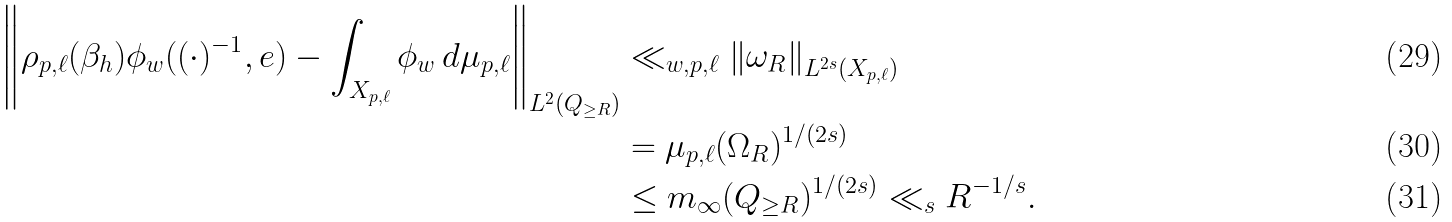Convert formula to latex. <formula><loc_0><loc_0><loc_500><loc_500>\left \| \rho _ { p , \ell } ( \beta _ { h } ) \phi _ { w } ( ( \cdot ) ^ { - 1 } , e ) - \int _ { X _ { p , \ell } } \phi _ { w } \, d \mu _ { p , \ell } \right \| _ { L ^ { 2 } ( Q _ { \geq R } ) } & \ll _ { w , p , \ell } \left \| \omega _ { R } \right \| _ { L ^ { 2 s } ( X _ { p , \ell } ) } \\ & = \mu _ { p , \ell } ( \Omega _ { R } ) ^ { 1 / ( 2 s ) } \\ & \leq m _ { \infty } ( Q _ { \geq R } ) ^ { 1 / ( 2 s ) } \ll _ { s } R ^ { - 1 / s } .</formula> 